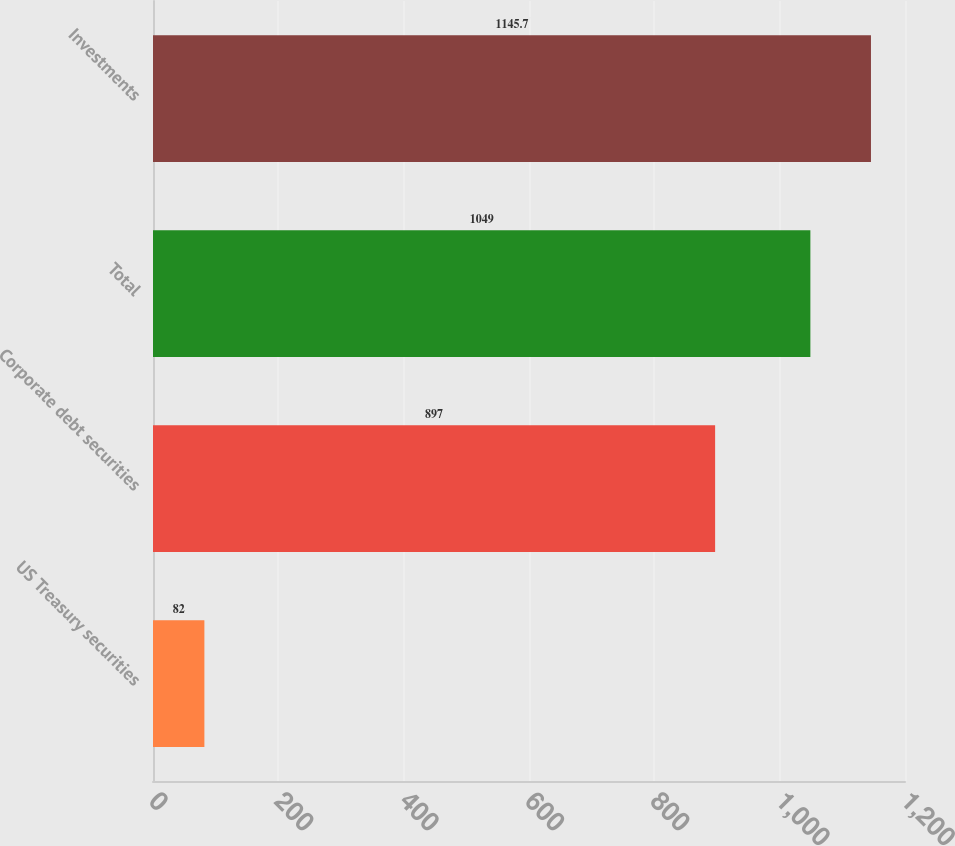Convert chart. <chart><loc_0><loc_0><loc_500><loc_500><bar_chart><fcel>US Treasury securities<fcel>Corporate debt securities<fcel>Total<fcel>Investments<nl><fcel>82<fcel>897<fcel>1049<fcel>1145.7<nl></chart> 